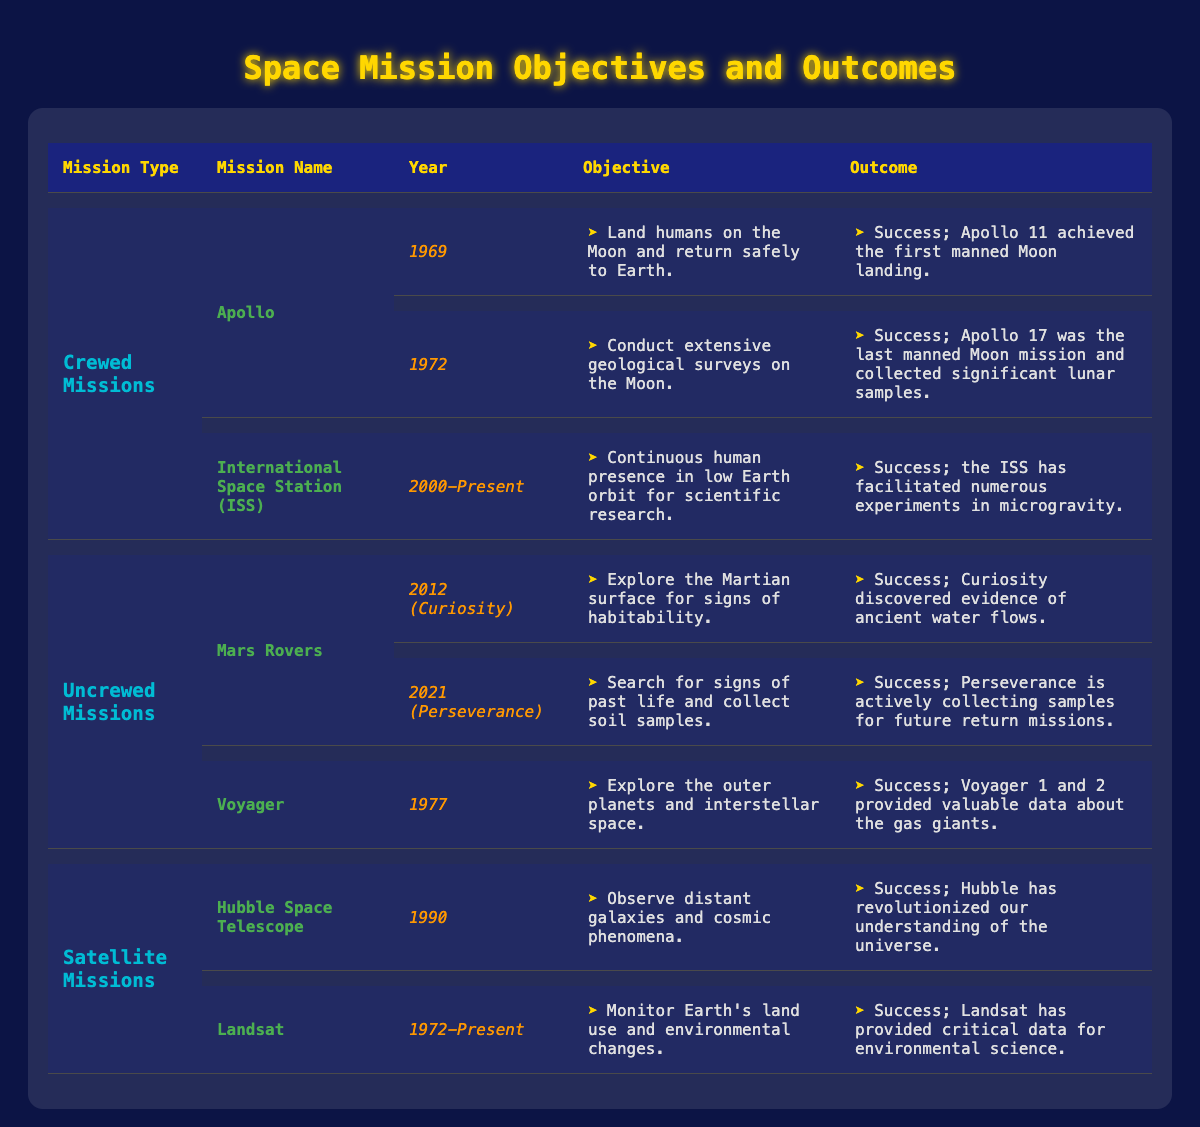What was the objective of the Apollo 11 mission? The table indicates that the objective of the Apollo 11 mission in 1969 was to land humans on the Moon and return safely to Earth. This information is directly listed under the Apollo mission row for that year.
Answer: Land humans on the Moon and return safely to Earth How many crewed missions are listed in the table? The table shows three crewed missions: Apollo (two years) and the International Space Station (ISS) spanning 2000 to present. Therefore, the total count is three unique mission types under the Crewed Missions category.
Answer: 3 Did the Voyager mission succeed? According to the table, the Voyager mission aimed to explore the outer planets and interstellar space, and it is noted as a success. Therefore, the answer is yes.
Answer: Yes What is the objective of the Mars Perseverance Rover mission? The table specifies that the objective of the Perseverance mission in 2021 is to search for signs of past life and collect soil samples. This information can be found in the Mars Rovers section under the Perseverance entry.
Answer: Search for signs of past life and collect soil samples Which mission type has the most missions listed in the table? Looking at the table, the Crewed Missions and Uncrewed Missions both have three missions, while Satellite Missions have only two. However, since each mission under Crewed and Uncrewed is by name and year, this indicates there is a tie.
Answer: Crewed Missions and Uncrewed Missions What is the outcome of the Hubble Space Telescope mission? The table states that the Hubble Space Telescope mission's outcome is success and that it has revolutionized our understanding of the universe. This can be confirmed by examining the corresponding row in the Satellite Missions section.
Answer: Success; it has revolutionized our understanding of the universe Count the number of successful missions listed in the data. By examining each mission's outcome, we find that all missions in the table (Apollo 11, Apollo 17, ISS, Curiosity, Perseverance, Voyager, Hubble, and Landsat) have a noted success. Therefore, we sum a total of 8 successful missions.
Answer: 8 Was the objective of the Landsat mission focused on space exploration? The table shows that the Landsat mission's objective is to monitor Earth's land use and environmental changes, which indicates that it is not focused on space exploration but rather on Earth observation. Hence, the answer is no.
Answer: No How many different years are represented in the Crewed Missions category? In the Crewed Missions section, the table lists Apollo missions in 1969 and 1972, and one for the ISS from 2000-Present. This results in three unique representations of years: 1969, 1972, and a range from 2000 onwards. Therefore, the unique count is three.
Answer: 3 